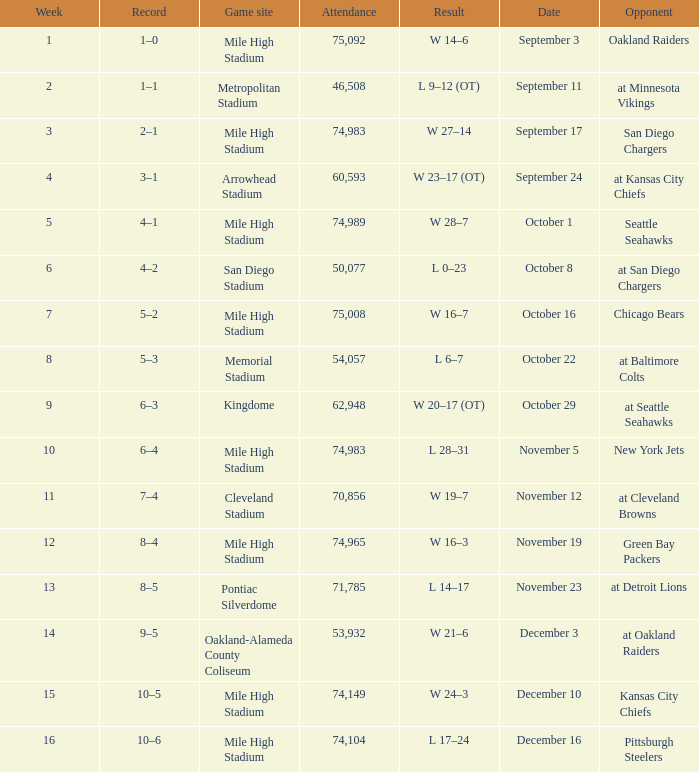Which week has a record of 5–2? 7.0. 